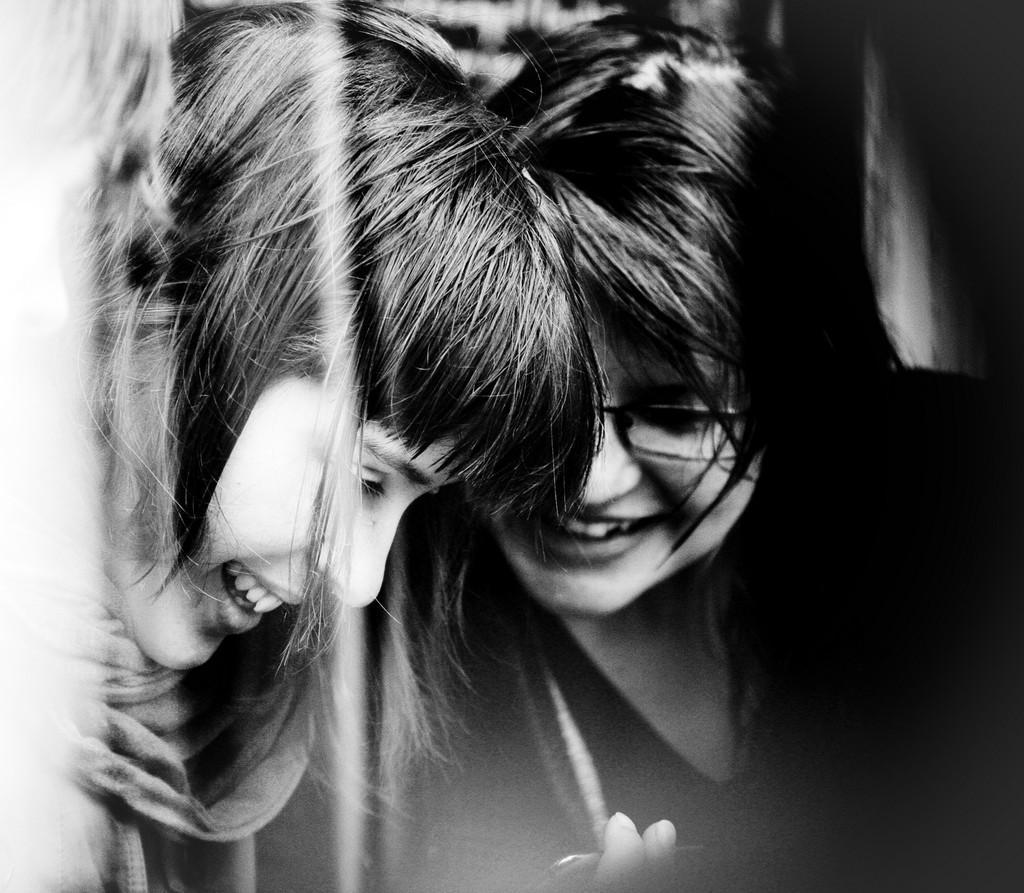In one or two sentences, can you explain what this image depicts? This image consists of two girls. It looks like a black and white image. The background is blurred. On the left, the girl is wearing a scarf. 